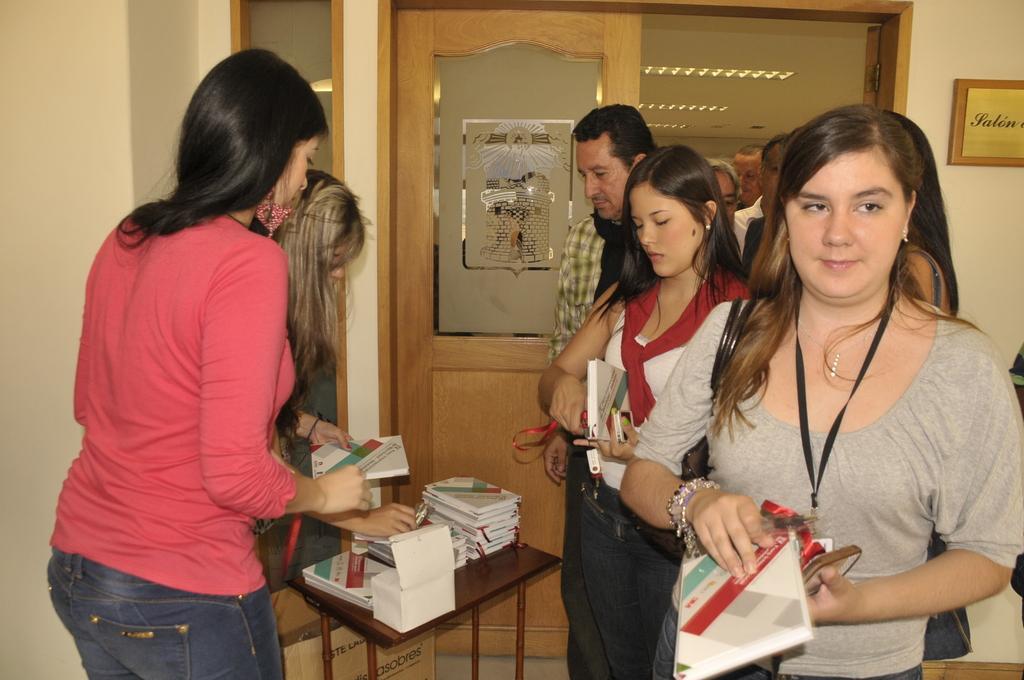Could you give a brief overview of what you see in this image? On the right side of the image we can see many persons coming from the door. On the left side of the image we can see person standing at the table. On the table we can see books. In the background we can see door, name board, wall and lights. 